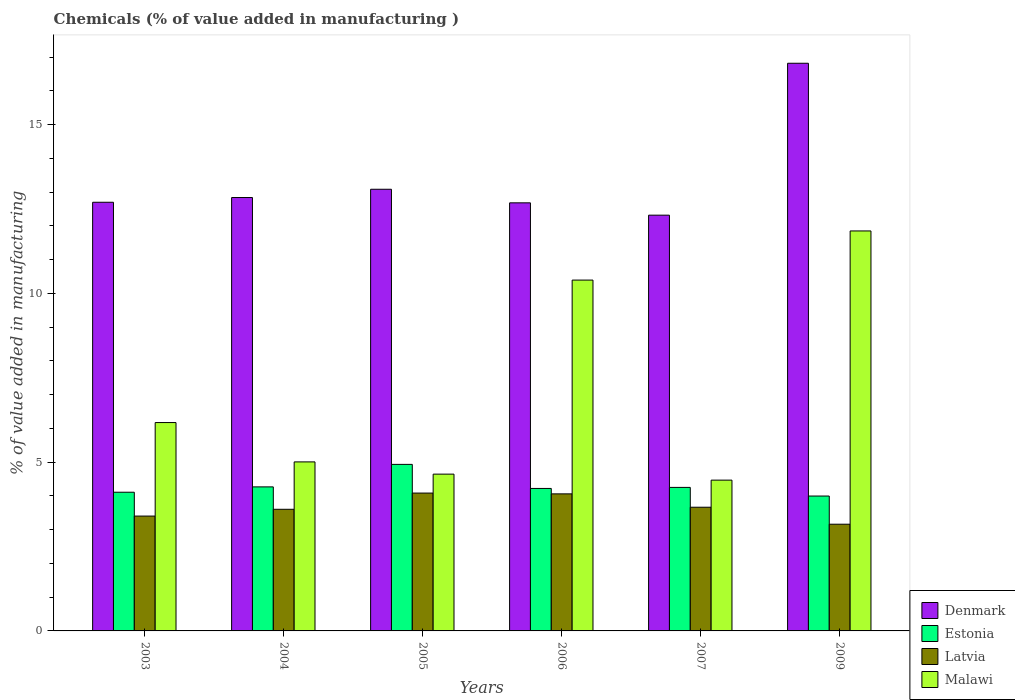How many different coloured bars are there?
Keep it short and to the point. 4. How many groups of bars are there?
Keep it short and to the point. 6. Are the number of bars per tick equal to the number of legend labels?
Offer a terse response. Yes. How many bars are there on the 4th tick from the left?
Make the answer very short. 4. How many bars are there on the 3rd tick from the right?
Provide a short and direct response. 4. What is the label of the 4th group of bars from the left?
Offer a terse response. 2006. In how many cases, is the number of bars for a given year not equal to the number of legend labels?
Your answer should be very brief. 0. What is the value added in manufacturing chemicals in Denmark in 2005?
Your answer should be compact. 13.08. Across all years, what is the maximum value added in manufacturing chemicals in Denmark?
Offer a very short reply. 16.82. Across all years, what is the minimum value added in manufacturing chemicals in Denmark?
Offer a very short reply. 12.32. In which year was the value added in manufacturing chemicals in Denmark minimum?
Offer a very short reply. 2007. What is the total value added in manufacturing chemicals in Malawi in the graph?
Keep it short and to the point. 42.53. What is the difference between the value added in manufacturing chemicals in Latvia in 2006 and that in 2007?
Your response must be concise. 0.4. What is the difference between the value added in manufacturing chemicals in Latvia in 2007 and the value added in manufacturing chemicals in Malawi in 2003?
Your answer should be very brief. -2.51. What is the average value added in manufacturing chemicals in Denmark per year?
Your answer should be compact. 13.41. In the year 2004, what is the difference between the value added in manufacturing chemicals in Denmark and value added in manufacturing chemicals in Malawi?
Provide a short and direct response. 7.83. In how many years, is the value added in manufacturing chemicals in Denmark greater than 5 %?
Give a very brief answer. 6. What is the ratio of the value added in manufacturing chemicals in Estonia in 2005 to that in 2007?
Offer a terse response. 1.16. Is the value added in manufacturing chemicals in Denmark in 2007 less than that in 2009?
Provide a succinct answer. Yes. Is the difference between the value added in manufacturing chemicals in Denmark in 2004 and 2005 greater than the difference between the value added in manufacturing chemicals in Malawi in 2004 and 2005?
Provide a short and direct response. No. What is the difference between the highest and the second highest value added in manufacturing chemicals in Denmark?
Your answer should be compact. 3.73. What is the difference between the highest and the lowest value added in manufacturing chemicals in Denmark?
Offer a terse response. 4.5. Is the sum of the value added in manufacturing chemicals in Denmark in 2004 and 2009 greater than the maximum value added in manufacturing chemicals in Malawi across all years?
Give a very brief answer. Yes. Is it the case that in every year, the sum of the value added in manufacturing chemicals in Malawi and value added in manufacturing chemicals in Estonia is greater than the sum of value added in manufacturing chemicals in Latvia and value added in manufacturing chemicals in Denmark?
Make the answer very short. No. What does the 1st bar from the left in 2004 represents?
Your answer should be compact. Denmark. What does the 2nd bar from the right in 2003 represents?
Give a very brief answer. Latvia. Are all the bars in the graph horizontal?
Ensure brevity in your answer.  No. What is the difference between two consecutive major ticks on the Y-axis?
Your response must be concise. 5. Are the values on the major ticks of Y-axis written in scientific E-notation?
Keep it short and to the point. No. Does the graph contain any zero values?
Keep it short and to the point. No. Where does the legend appear in the graph?
Give a very brief answer. Bottom right. How many legend labels are there?
Offer a terse response. 4. What is the title of the graph?
Your answer should be very brief. Chemicals (% of value added in manufacturing ). Does "Iceland" appear as one of the legend labels in the graph?
Offer a very short reply. No. What is the label or title of the X-axis?
Your answer should be very brief. Years. What is the label or title of the Y-axis?
Make the answer very short. % of value added in manufacturing. What is the % of value added in manufacturing in Denmark in 2003?
Your answer should be very brief. 12.7. What is the % of value added in manufacturing of Estonia in 2003?
Your answer should be very brief. 4.11. What is the % of value added in manufacturing in Latvia in 2003?
Your response must be concise. 3.4. What is the % of value added in manufacturing in Malawi in 2003?
Ensure brevity in your answer.  6.17. What is the % of value added in manufacturing in Denmark in 2004?
Make the answer very short. 12.84. What is the % of value added in manufacturing of Estonia in 2004?
Ensure brevity in your answer.  4.27. What is the % of value added in manufacturing in Latvia in 2004?
Provide a short and direct response. 3.6. What is the % of value added in manufacturing in Malawi in 2004?
Keep it short and to the point. 5.01. What is the % of value added in manufacturing in Denmark in 2005?
Keep it short and to the point. 13.08. What is the % of value added in manufacturing of Estonia in 2005?
Your answer should be compact. 4.93. What is the % of value added in manufacturing of Latvia in 2005?
Your answer should be compact. 4.08. What is the % of value added in manufacturing in Malawi in 2005?
Ensure brevity in your answer.  4.64. What is the % of value added in manufacturing of Denmark in 2006?
Provide a succinct answer. 12.68. What is the % of value added in manufacturing of Estonia in 2006?
Your answer should be compact. 4.22. What is the % of value added in manufacturing in Latvia in 2006?
Ensure brevity in your answer.  4.06. What is the % of value added in manufacturing of Malawi in 2006?
Your answer should be compact. 10.39. What is the % of value added in manufacturing in Denmark in 2007?
Give a very brief answer. 12.32. What is the % of value added in manufacturing of Estonia in 2007?
Your response must be concise. 4.25. What is the % of value added in manufacturing in Latvia in 2007?
Provide a short and direct response. 3.66. What is the % of value added in manufacturing of Malawi in 2007?
Give a very brief answer. 4.47. What is the % of value added in manufacturing of Denmark in 2009?
Provide a succinct answer. 16.82. What is the % of value added in manufacturing in Estonia in 2009?
Provide a succinct answer. 4. What is the % of value added in manufacturing in Latvia in 2009?
Make the answer very short. 3.16. What is the % of value added in manufacturing of Malawi in 2009?
Your response must be concise. 11.85. Across all years, what is the maximum % of value added in manufacturing of Denmark?
Provide a short and direct response. 16.82. Across all years, what is the maximum % of value added in manufacturing in Estonia?
Offer a very short reply. 4.93. Across all years, what is the maximum % of value added in manufacturing of Latvia?
Offer a terse response. 4.08. Across all years, what is the maximum % of value added in manufacturing in Malawi?
Provide a succinct answer. 11.85. Across all years, what is the minimum % of value added in manufacturing in Denmark?
Offer a very short reply. 12.32. Across all years, what is the minimum % of value added in manufacturing in Estonia?
Ensure brevity in your answer.  4. Across all years, what is the minimum % of value added in manufacturing in Latvia?
Provide a succinct answer. 3.16. Across all years, what is the minimum % of value added in manufacturing of Malawi?
Provide a short and direct response. 4.47. What is the total % of value added in manufacturing in Denmark in the graph?
Your response must be concise. 80.44. What is the total % of value added in manufacturing of Estonia in the graph?
Keep it short and to the point. 25.78. What is the total % of value added in manufacturing of Latvia in the graph?
Give a very brief answer. 21.97. What is the total % of value added in manufacturing in Malawi in the graph?
Ensure brevity in your answer.  42.53. What is the difference between the % of value added in manufacturing in Denmark in 2003 and that in 2004?
Offer a very short reply. -0.14. What is the difference between the % of value added in manufacturing in Estonia in 2003 and that in 2004?
Offer a very short reply. -0.16. What is the difference between the % of value added in manufacturing of Latvia in 2003 and that in 2004?
Make the answer very short. -0.2. What is the difference between the % of value added in manufacturing of Malawi in 2003 and that in 2004?
Make the answer very short. 1.17. What is the difference between the % of value added in manufacturing of Denmark in 2003 and that in 2005?
Give a very brief answer. -0.39. What is the difference between the % of value added in manufacturing of Estonia in 2003 and that in 2005?
Provide a succinct answer. -0.82. What is the difference between the % of value added in manufacturing of Latvia in 2003 and that in 2005?
Keep it short and to the point. -0.68. What is the difference between the % of value added in manufacturing in Malawi in 2003 and that in 2005?
Your answer should be very brief. 1.53. What is the difference between the % of value added in manufacturing of Denmark in 2003 and that in 2006?
Offer a very short reply. 0.02. What is the difference between the % of value added in manufacturing in Estonia in 2003 and that in 2006?
Your answer should be compact. -0.11. What is the difference between the % of value added in manufacturing of Latvia in 2003 and that in 2006?
Keep it short and to the point. -0.66. What is the difference between the % of value added in manufacturing of Malawi in 2003 and that in 2006?
Ensure brevity in your answer.  -4.22. What is the difference between the % of value added in manufacturing of Denmark in 2003 and that in 2007?
Keep it short and to the point. 0.38. What is the difference between the % of value added in manufacturing in Estonia in 2003 and that in 2007?
Offer a very short reply. -0.14. What is the difference between the % of value added in manufacturing in Latvia in 2003 and that in 2007?
Your response must be concise. -0.26. What is the difference between the % of value added in manufacturing in Malawi in 2003 and that in 2007?
Ensure brevity in your answer.  1.71. What is the difference between the % of value added in manufacturing in Denmark in 2003 and that in 2009?
Make the answer very short. -4.12. What is the difference between the % of value added in manufacturing in Estonia in 2003 and that in 2009?
Your answer should be compact. 0.11. What is the difference between the % of value added in manufacturing of Latvia in 2003 and that in 2009?
Make the answer very short. 0.24. What is the difference between the % of value added in manufacturing in Malawi in 2003 and that in 2009?
Offer a terse response. -5.68. What is the difference between the % of value added in manufacturing in Denmark in 2004 and that in 2005?
Ensure brevity in your answer.  -0.24. What is the difference between the % of value added in manufacturing of Latvia in 2004 and that in 2005?
Provide a succinct answer. -0.48. What is the difference between the % of value added in manufacturing in Malawi in 2004 and that in 2005?
Give a very brief answer. 0.36. What is the difference between the % of value added in manufacturing in Denmark in 2004 and that in 2006?
Provide a short and direct response. 0.16. What is the difference between the % of value added in manufacturing of Estonia in 2004 and that in 2006?
Give a very brief answer. 0.05. What is the difference between the % of value added in manufacturing in Latvia in 2004 and that in 2006?
Your answer should be very brief. -0.46. What is the difference between the % of value added in manufacturing in Malawi in 2004 and that in 2006?
Provide a short and direct response. -5.39. What is the difference between the % of value added in manufacturing in Denmark in 2004 and that in 2007?
Ensure brevity in your answer.  0.52. What is the difference between the % of value added in manufacturing of Estonia in 2004 and that in 2007?
Offer a terse response. 0.02. What is the difference between the % of value added in manufacturing of Latvia in 2004 and that in 2007?
Give a very brief answer. -0.06. What is the difference between the % of value added in manufacturing in Malawi in 2004 and that in 2007?
Keep it short and to the point. 0.54. What is the difference between the % of value added in manufacturing in Denmark in 2004 and that in 2009?
Ensure brevity in your answer.  -3.98. What is the difference between the % of value added in manufacturing in Estonia in 2004 and that in 2009?
Make the answer very short. 0.27. What is the difference between the % of value added in manufacturing in Latvia in 2004 and that in 2009?
Give a very brief answer. 0.44. What is the difference between the % of value added in manufacturing of Malawi in 2004 and that in 2009?
Your answer should be very brief. -6.84. What is the difference between the % of value added in manufacturing in Denmark in 2005 and that in 2006?
Offer a very short reply. 0.4. What is the difference between the % of value added in manufacturing in Estonia in 2005 and that in 2006?
Your answer should be very brief. 0.71. What is the difference between the % of value added in manufacturing in Latvia in 2005 and that in 2006?
Ensure brevity in your answer.  0.02. What is the difference between the % of value added in manufacturing in Malawi in 2005 and that in 2006?
Provide a short and direct response. -5.75. What is the difference between the % of value added in manufacturing in Denmark in 2005 and that in 2007?
Your response must be concise. 0.77. What is the difference between the % of value added in manufacturing of Estonia in 2005 and that in 2007?
Ensure brevity in your answer.  0.68. What is the difference between the % of value added in manufacturing of Latvia in 2005 and that in 2007?
Provide a short and direct response. 0.42. What is the difference between the % of value added in manufacturing in Malawi in 2005 and that in 2007?
Make the answer very short. 0.18. What is the difference between the % of value added in manufacturing of Denmark in 2005 and that in 2009?
Provide a short and direct response. -3.73. What is the difference between the % of value added in manufacturing in Estonia in 2005 and that in 2009?
Your response must be concise. 0.94. What is the difference between the % of value added in manufacturing of Latvia in 2005 and that in 2009?
Keep it short and to the point. 0.92. What is the difference between the % of value added in manufacturing of Malawi in 2005 and that in 2009?
Your answer should be very brief. -7.2. What is the difference between the % of value added in manufacturing of Denmark in 2006 and that in 2007?
Your response must be concise. 0.37. What is the difference between the % of value added in manufacturing of Estonia in 2006 and that in 2007?
Your response must be concise. -0.03. What is the difference between the % of value added in manufacturing of Latvia in 2006 and that in 2007?
Your answer should be very brief. 0.4. What is the difference between the % of value added in manufacturing of Malawi in 2006 and that in 2007?
Provide a succinct answer. 5.93. What is the difference between the % of value added in manufacturing in Denmark in 2006 and that in 2009?
Your answer should be very brief. -4.13. What is the difference between the % of value added in manufacturing of Estonia in 2006 and that in 2009?
Your answer should be very brief. 0.22. What is the difference between the % of value added in manufacturing of Latvia in 2006 and that in 2009?
Provide a succinct answer. 0.9. What is the difference between the % of value added in manufacturing of Malawi in 2006 and that in 2009?
Give a very brief answer. -1.46. What is the difference between the % of value added in manufacturing in Denmark in 2007 and that in 2009?
Keep it short and to the point. -4.5. What is the difference between the % of value added in manufacturing in Estonia in 2007 and that in 2009?
Provide a succinct answer. 0.26. What is the difference between the % of value added in manufacturing of Latvia in 2007 and that in 2009?
Offer a terse response. 0.5. What is the difference between the % of value added in manufacturing in Malawi in 2007 and that in 2009?
Offer a very short reply. -7.38. What is the difference between the % of value added in manufacturing of Denmark in 2003 and the % of value added in manufacturing of Estonia in 2004?
Offer a very short reply. 8.43. What is the difference between the % of value added in manufacturing in Denmark in 2003 and the % of value added in manufacturing in Latvia in 2004?
Your answer should be compact. 9.1. What is the difference between the % of value added in manufacturing of Denmark in 2003 and the % of value added in manufacturing of Malawi in 2004?
Offer a very short reply. 7.69. What is the difference between the % of value added in manufacturing in Estonia in 2003 and the % of value added in manufacturing in Latvia in 2004?
Offer a terse response. 0.51. What is the difference between the % of value added in manufacturing in Estonia in 2003 and the % of value added in manufacturing in Malawi in 2004?
Your answer should be very brief. -0.9. What is the difference between the % of value added in manufacturing in Latvia in 2003 and the % of value added in manufacturing in Malawi in 2004?
Make the answer very short. -1.6. What is the difference between the % of value added in manufacturing in Denmark in 2003 and the % of value added in manufacturing in Estonia in 2005?
Your response must be concise. 7.77. What is the difference between the % of value added in manufacturing of Denmark in 2003 and the % of value added in manufacturing of Latvia in 2005?
Offer a very short reply. 8.62. What is the difference between the % of value added in manufacturing in Denmark in 2003 and the % of value added in manufacturing in Malawi in 2005?
Your answer should be very brief. 8.05. What is the difference between the % of value added in manufacturing of Estonia in 2003 and the % of value added in manufacturing of Latvia in 2005?
Your response must be concise. 0.02. What is the difference between the % of value added in manufacturing in Estonia in 2003 and the % of value added in manufacturing in Malawi in 2005?
Offer a very short reply. -0.54. What is the difference between the % of value added in manufacturing in Latvia in 2003 and the % of value added in manufacturing in Malawi in 2005?
Your answer should be very brief. -1.24. What is the difference between the % of value added in manufacturing of Denmark in 2003 and the % of value added in manufacturing of Estonia in 2006?
Your response must be concise. 8.48. What is the difference between the % of value added in manufacturing in Denmark in 2003 and the % of value added in manufacturing in Latvia in 2006?
Give a very brief answer. 8.64. What is the difference between the % of value added in manufacturing in Denmark in 2003 and the % of value added in manufacturing in Malawi in 2006?
Give a very brief answer. 2.31. What is the difference between the % of value added in manufacturing in Estonia in 2003 and the % of value added in manufacturing in Latvia in 2006?
Make the answer very short. 0.05. What is the difference between the % of value added in manufacturing of Estonia in 2003 and the % of value added in manufacturing of Malawi in 2006?
Give a very brief answer. -6.28. What is the difference between the % of value added in manufacturing of Latvia in 2003 and the % of value added in manufacturing of Malawi in 2006?
Keep it short and to the point. -6.99. What is the difference between the % of value added in manufacturing in Denmark in 2003 and the % of value added in manufacturing in Estonia in 2007?
Make the answer very short. 8.45. What is the difference between the % of value added in manufacturing of Denmark in 2003 and the % of value added in manufacturing of Latvia in 2007?
Offer a very short reply. 9.03. What is the difference between the % of value added in manufacturing of Denmark in 2003 and the % of value added in manufacturing of Malawi in 2007?
Keep it short and to the point. 8.23. What is the difference between the % of value added in manufacturing in Estonia in 2003 and the % of value added in manufacturing in Latvia in 2007?
Your response must be concise. 0.44. What is the difference between the % of value added in manufacturing of Estonia in 2003 and the % of value added in manufacturing of Malawi in 2007?
Your response must be concise. -0.36. What is the difference between the % of value added in manufacturing of Latvia in 2003 and the % of value added in manufacturing of Malawi in 2007?
Your answer should be very brief. -1.06. What is the difference between the % of value added in manufacturing of Denmark in 2003 and the % of value added in manufacturing of Estonia in 2009?
Make the answer very short. 8.7. What is the difference between the % of value added in manufacturing in Denmark in 2003 and the % of value added in manufacturing in Latvia in 2009?
Provide a succinct answer. 9.54. What is the difference between the % of value added in manufacturing in Denmark in 2003 and the % of value added in manufacturing in Malawi in 2009?
Provide a short and direct response. 0.85. What is the difference between the % of value added in manufacturing of Estonia in 2003 and the % of value added in manufacturing of Latvia in 2009?
Your answer should be compact. 0.95. What is the difference between the % of value added in manufacturing of Estonia in 2003 and the % of value added in manufacturing of Malawi in 2009?
Make the answer very short. -7.74. What is the difference between the % of value added in manufacturing of Latvia in 2003 and the % of value added in manufacturing of Malawi in 2009?
Give a very brief answer. -8.45. What is the difference between the % of value added in manufacturing of Denmark in 2004 and the % of value added in manufacturing of Estonia in 2005?
Your answer should be compact. 7.91. What is the difference between the % of value added in manufacturing in Denmark in 2004 and the % of value added in manufacturing in Latvia in 2005?
Your response must be concise. 8.76. What is the difference between the % of value added in manufacturing of Denmark in 2004 and the % of value added in manufacturing of Malawi in 2005?
Offer a terse response. 8.19. What is the difference between the % of value added in manufacturing in Estonia in 2004 and the % of value added in manufacturing in Latvia in 2005?
Your answer should be very brief. 0.18. What is the difference between the % of value added in manufacturing of Estonia in 2004 and the % of value added in manufacturing of Malawi in 2005?
Your response must be concise. -0.38. What is the difference between the % of value added in manufacturing of Latvia in 2004 and the % of value added in manufacturing of Malawi in 2005?
Offer a very short reply. -1.04. What is the difference between the % of value added in manufacturing of Denmark in 2004 and the % of value added in manufacturing of Estonia in 2006?
Provide a short and direct response. 8.62. What is the difference between the % of value added in manufacturing in Denmark in 2004 and the % of value added in manufacturing in Latvia in 2006?
Ensure brevity in your answer.  8.78. What is the difference between the % of value added in manufacturing of Denmark in 2004 and the % of value added in manufacturing of Malawi in 2006?
Keep it short and to the point. 2.45. What is the difference between the % of value added in manufacturing in Estonia in 2004 and the % of value added in manufacturing in Latvia in 2006?
Offer a very short reply. 0.21. What is the difference between the % of value added in manufacturing in Estonia in 2004 and the % of value added in manufacturing in Malawi in 2006?
Give a very brief answer. -6.13. What is the difference between the % of value added in manufacturing in Latvia in 2004 and the % of value added in manufacturing in Malawi in 2006?
Your response must be concise. -6.79. What is the difference between the % of value added in manufacturing in Denmark in 2004 and the % of value added in manufacturing in Estonia in 2007?
Your answer should be very brief. 8.59. What is the difference between the % of value added in manufacturing in Denmark in 2004 and the % of value added in manufacturing in Latvia in 2007?
Offer a terse response. 9.17. What is the difference between the % of value added in manufacturing in Denmark in 2004 and the % of value added in manufacturing in Malawi in 2007?
Provide a succinct answer. 8.37. What is the difference between the % of value added in manufacturing of Estonia in 2004 and the % of value added in manufacturing of Latvia in 2007?
Offer a terse response. 0.6. What is the difference between the % of value added in manufacturing in Estonia in 2004 and the % of value added in manufacturing in Malawi in 2007?
Keep it short and to the point. -0.2. What is the difference between the % of value added in manufacturing of Latvia in 2004 and the % of value added in manufacturing of Malawi in 2007?
Keep it short and to the point. -0.86. What is the difference between the % of value added in manufacturing in Denmark in 2004 and the % of value added in manufacturing in Estonia in 2009?
Make the answer very short. 8.84. What is the difference between the % of value added in manufacturing in Denmark in 2004 and the % of value added in manufacturing in Latvia in 2009?
Your answer should be compact. 9.68. What is the difference between the % of value added in manufacturing in Estonia in 2004 and the % of value added in manufacturing in Latvia in 2009?
Make the answer very short. 1.11. What is the difference between the % of value added in manufacturing of Estonia in 2004 and the % of value added in manufacturing of Malawi in 2009?
Your answer should be very brief. -7.58. What is the difference between the % of value added in manufacturing of Latvia in 2004 and the % of value added in manufacturing of Malawi in 2009?
Your answer should be compact. -8.25. What is the difference between the % of value added in manufacturing in Denmark in 2005 and the % of value added in manufacturing in Estonia in 2006?
Your response must be concise. 8.86. What is the difference between the % of value added in manufacturing of Denmark in 2005 and the % of value added in manufacturing of Latvia in 2006?
Provide a short and direct response. 9.02. What is the difference between the % of value added in manufacturing of Denmark in 2005 and the % of value added in manufacturing of Malawi in 2006?
Your answer should be very brief. 2.69. What is the difference between the % of value added in manufacturing in Estonia in 2005 and the % of value added in manufacturing in Latvia in 2006?
Provide a short and direct response. 0.87. What is the difference between the % of value added in manufacturing of Estonia in 2005 and the % of value added in manufacturing of Malawi in 2006?
Offer a very short reply. -5.46. What is the difference between the % of value added in manufacturing of Latvia in 2005 and the % of value added in manufacturing of Malawi in 2006?
Offer a terse response. -6.31. What is the difference between the % of value added in manufacturing in Denmark in 2005 and the % of value added in manufacturing in Estonia in 2007?
Give a very brief answer. 8.83. What is the difference between the % of value added in manufacturing of Denmark in 2005 and the % of value added in manufacturing of Latvia in 2007?
Give a very brief answer. 9.42. What is the difference between the % of value added in manufacturing in Denmark in 2005 and the % of value added in manufacturing in Malawi in 2007?
Give a very brief answer. 8.62. What is the difference between the % of value added in manufacturing of Estonia in 2005 and the % of value added in manufacturing of Latvia in 2007?
Offer a terse response. 1.27. What is the difference between the % of value added in manufacturing of Estonia in 2005 and the % of value added in manufacturing of Malawi in 2007?
Ensure brevity in your answer.  0.47. What is the difference between the % of value added in manufacturing of Latvia in 2005 and the % of value added in manufacturing of Malawi in 2007?
Keep it short and to the point. -0.38. What is the difference between the % of value added in manufacturing in Denmark in 2005 and the % of value added in manufacturing in Estonia in 2009?
Offer a terse response. 9.09. What is the difference between the % of value added in manufacturing of Denmark in 2005 and the % of value added in manufacturing of Latvia in 2009?
Give a very brief answer. 9.92. What is the difference between the % of value added in manufacturing of Denmark in 2005 and the % of value added in manufacturing of Malawi in 2009?
Your answer should be compact. 1.23. What is the difference between the % of value added in manufacturing in Estonia in 2005 and the % of value added in manufacturing in Latvia in 2009?
Offer a very short reply. 1.77. What is the difference between the % of value added in manufacturing in Estonia in 2005 and the % of value added in manufacturing in Malawi in 2009?
Ensure brevity in your answer.  -6.92. What is the difference between the % of value added in manufacturing of Latvia in 2005 and the % of value added in manufacturing of Malawi in 2009?
Provide a short and direct response. -7.77. What is the difference between the % of value added in manufacturing in Denmark in 2006 and the % of value added in manufacturing in Estonia in 2007?
Ensure brevity in your answer.  8.43. What is the difference between the % of value added in manufacturing of Denmark in 2006 and the % of value added in manufacturing of Latvia in 2007?
Provide a succinct answer. 9.02. What is the difference between the % of value added in manufacturing in Denmark in 2006 and the % of value added in manufacturing in Malawi in 2007?
Your answer should be compact. 8.21. What is the difference between the % of value added in manufacturing of Estonia in 2006 and the % of value added in manufacturing of Latvia in 2007?
Your answer should be very brief. 0.56. What is the difference between the % of value added in manufacturing in Estonia in 2006 and the % of value added in manufacturing in Malawi in 2007?
Offer a very short reply. -0.25. What is the difference between the % of value added in manufacturing of Latvia in 2006 and the % of value added in manufacturing of Malawi in 2007?
Ensure brevity in your answer.  -0.41. What is the difference between the % of value added in manufacturing in Denmark in 2006 and the % of value added in manufacturing in Estonia in 2009?
Your answer should be very brief. 8.69. What is the difference between the % of value added in manufacturing of Denmark in 2006 and the % of value added in manufacturing of Latvia in 2009?
Your answer should be compact. 9.52. What is the difference between the % of value added in manufacturing of Denmark in 2006 and the % of value added in manufacturing of Malawi in 2009?
Keep it short and to the point. 0.83. What is the difference between the % of value added in manufacturing in Estonia in 2006 and the % of value added in manufacturing in Latvia in 2009?
Keep it short and to the point. 1.06. What is the difference between the % of value added in manufacturing of Estonia in 2006 and the % of value added in manufacturing of Malawi in 2009?
Your response must be concise. -7.63. What is the difference between the % of value added in manufacturing in Latvia in 2006 and the % of value added in manufacturing in Malawi in 2009?
Give a very brief answer. -7.79. What is the difference between the % of value added in manufacturing in Denmark in 2007 and the % of value added in manufacturing in Estonia in 2009?
Make the answer very short. 8.32. What is the difference between the % of value added in manufacturing of Denmark in 2007 and the % of value added in manufacturing of Latvia in 2009?
Give a very brief answer. 9.16. What is the difference between the % of value added in manufacturing of Denmark in 2007 and the % of value added in manufacturing of Malawi in 2009?
Your answer should be compact. 0.47. What is the difference between the % of value added in manufacturing of Estonia in 2007 and the % of value added in manufacturing of Latvia in 2009?
Make the answer very short. 1.09. What is the difference between the % of value added in manufacturing of Estonia in 2007 and the % of value added in manufacturing of Malawi in 2009?
Ensure brevity in your answer.  -7.6. What is the difference between the % of value added in manufacturing in Latvia in 2007 and the % of value added in manufacturing in Malawi in 2009?
Keep it short and to the point. -8.18. What is the average % of value added in manufacturing of Denmark per year?
Give a very brief answer. 13.41. What is the average % of value added in manufacturing of Estonia per year?
Your answer should be compact. 4.3. What is the average % of value added in manufacturing of Latvia per year?
Ensure brevity in your answer.  3.66. What is the average % of value added in manufacturing of Malawi per year?
Your response must be concise. 7.09. In the year 2003, what is the difference between the % of value added in manufacturing in Denmark and % of value added in manufacturing in Estonia?
Offer a very short reply. 8.59. In the year 2003, what is the difference between the % of value added in manufacturing of Denmark and % of value added in manufacturing of Latvia?
Offer a terse response. 9.3. In the year 2003, what is the difference between the % of value added in manufacturing in Denmark and % of value added in manufacturing in Malawi?
Provide a short and direct response. 6.53. In the year 2003, what is the difference between the % of value added in manufacturing of Estonia and % of value added in manufacturing of Latvia?
Provide a succinct answer. 0.71. In the year 2003, what is the difference between the % of value added in manufacturing of Estonia and % of value added in manufacturing of Malawi?
Offer a terse response. -2.06. In the year 2003, what is the difference between the % of value added in manufacturing of Latvia and % of value added in manufacturing of Malawi?
Your answer should be compact. -2.77. In the year 2004, what is the difference between the % of value added in manufacturing of Denmark and % of value added in manufacturing of Estonia?
Provide a succinct answer. 8.57. In the year 2004, what is the difference between the % of value added in manufacturing in Denmark and % of value added in manufacturing in Latvia?
Offer a terse response. 9.24. In the year 2004, what is the difference between the % of value added in manufacturing in Denmark and % of value added in manufacturing in Malawi?
Keep it short and to the point. 7.83. In the year 2004, what is the difference between the % of value added in manufacturing in Estonia and % of value added in manufacturing in Latvia?
Ensure brevity in your answer.  0.66. In the year 2004, what is the difference between the % of value added in manufacturing of Estonia and % of value added in manufacturing of Malawi?
Keep it short and to the point. -0.74. In the year 2004, what is the difference between the % of value added in manufacturing in Latvia and % of value added in manufacturing in Malawi?
Your answer should be compact. -1.4. In the year 2005, what is the difference between the % of value added in manufacturing of Denmark and % of value added in manufacturing of Estonia?
Ensure brevity in your answer.  8.15. In the year 2005, what is the difference between the % of value added in manufacturing in Denmark and % of value added in manufacturing in Latvia?
Your answer should be compact. 9. In the year 2005, what is the difference between the % of value added in manufacturing in Denmark and % of value added in manufacturing in Malawi?
Keep it short and to the point. 8.44. In the year 2005, what is the difference between the % of value added in manufacturing in Estonia and % of value added in manufacturing in Latvia?
Your answer should be very brief. 0.85. In the year 2005, what is the difference between the % of value added in manufacturing of Estonia and % of value added in manufacturing of Malawi?
Your answer should be compact. 0.29. In the year 2005, what is the difference between the % of value added in manufacturing of Latvia and % of value added in manufacturing of Malawi?
Your answer should be very brief. -0.56. In the year 2006, what is the difference between the % of value added in manufacturing in Denmark and % of value added in manufacturing in Estonia?
Your answer should be very brief. 8.46. In the year 2006, what is the difference between the % of value added in manufacturing in Denmark and % of value added in manufacturing in Latvia?
Provide a succinct answer. 8.62. In the year 2006, what is the difference between the % of value added in manufacturing of Denmark and % of value added in manufacturing of Malawi?
Provide a short and direct response. 2.29. In the year 2006, what is the difference between the % of value added in manufacturing of Estonia and % of value added in manufacturing of Latvia?
Your response must be concise. 0.16. In the year 2006, what is the difference between the % of value added in manufacturing in Estonia and % of value added in manufacturing in Malawi?
Offer a terse response. -6.17. In the year 2006, what is the difference between the % of value added in manufacturing of Latvia and % of value added in manufacturing of Malawi?
Your answer should be compact. -6.33. In the year 2007, what is the difference between the % of value added in manufacturing in Denmark and % of value added in manufacturing in Estonia?
Ensure brevity in your answer.  8.06. In the year 2007, what is the difference between the % of value added in manufacturing of Denmark and % of value added in manufacturing of Latvia?
Offer a terse response. 8.65. In the year 2007, what is the difference between the % of value added in manufacturing in Denmark and % of value added in manufacturing in Malawi?
Provide a short and direct response. 7.85. In the year 2007, what is the difference between the % of value added in manufacturing of Estonia and % of value added in manufacturing of Latvia?
Offer a very short reply. 0.59. In the year 2007, what is the difference between the % of value added in manufacturing of Estonia and % of value added in manufacturing of Malawi?
Your answer should be compact. -0.22. In the year 2007, what is the difference between the % of value added in manufacturing in Latvia and % of value added in manufacturing in Malawi?
Provide a short and direct response. -0.8. In the year 2009, what is the difference between the % of value added in manufacturing in Denmark and % of value added in manufacturing in Estonia?
Your response must be concise. 12.82. In the year 2009, what is the difference between the % of value added in manufacturing of Denmark and % of value added in manufacturing of Latvia?
Your answer should be very brief. 13.66. In the year 2009, what is the difference between the % of value added in manufacturing in Denmark and % of value added in manufacturing in Malawi?
Your answer should be very brief. 4.97. In the year 2009, what is the difference between the % of value added in manufacturing of Estonia and % of value added in manufacturing of Latvia?
Your answer should be compact. 0.83. In the year 2009, what is the difference between the % of value added in manufacturing of Estonia and % of value added in manufacturing of Malawi?
Your answer should be very brief. -7.85. In the year 2009, what is the difference between the % of value added in manufacturing of Latvia and % of value added in manufacturing of Malawi?
Keep it short and to the point. -8.69. What is the ratio of the % of value added in manufacturing in Denmark in 2003 to that in 2004?
Your answer should be compact. 0.99. What is the ratio of the % of value added in manufacturing in Estonia in 2003 to that in 2004?
Provide a short and direct response. 0.96. What is the ratio of the % of value added in manufacturing in Latvia in 2003 to that in 2004?
Ensure brevity in your answer.  0.94. What is the ratio of the % of value added in manufacturing in Malawi in 2003 to that in 2004?
Provide a short and direct response. 1.23. What is the ratio of the % of value added in manufacturing in Denmark in 2003 to that in 2005?
Your response must be concise. 0.97. What is the ratio of the % of value added in manufacturing in Estonia in 2003 to that in 2005?
Provide a short and direct response. 0.83. What is the ratio of the % of value added in manufacturing of Latvia in 2003 to that in 2005?
Give a very brief answer. 0.83. What is the ratio of the % of value added in manufacturing of Malawi in 2003 to that in 2005?
Your response must be concise. 1.33. What is the ratio of the % of value added in manufacturing of Denmark in 2003 to that in 2006?
Your answer should be very brief. 1. What is the ratio of the % of value added in manufacturing of Estonia in 2003 to that in 2006?
Your answer should be compact. 0.97. What is the ratio of the % of value added in manufacturing of Latvia in 2003 to that in 2006?
Your response must be concise. 0.84. What is the ratio of the % of value added in manufacturing of Malawi in 2003 to that in 2006?
Your response must be concise. 0.59. What is the ratio of the % of value added in manufacturing in Denmark in 2003 to that in 2007?
Provide a short and direct response. 1.03. What is the ratio of the % of value added in manufacturing of Estonia in 2003 to that in 2007?
Your answer should be compact. 0.97. What is the ratio of the % of value added in manufacturing of Latvia in 2003 to that in 2007?
Keep it short and to the point. 0.93. What is the ratio of the % of value added in manufacturing in Malawi in 2003 to that in 2007?
Provide a succinct answer. 1.38. What is the ratio of the % of value added in manufacturing in Denmark in 2003 to that in 2009?
Ensure brevity in your answer.  0.76. What is the ratio of the % of value added in manufacturing in Estonia in 2003 to that in 2009?
Give a very brief answer. 1.03. What is the ratio of the % of value added in manufacturing in Latvia in 2003 to that in 2009?
Provide a short and direct response. 1.08. What is the ratio of the % of value added in manufacturing in Malawi in 2003 to that in 2009?
Make the answer very short. 0.52. What is the ratio of the % of value added in manufacturing of Denmark in 2004 to that in 2005?
Provide a succinct answer. 0.98. What is the ratio of the % of value added in manufacturing in Estonia in 2004 to that in 2005?
Offer a very short reply. 0.86. What is the ratio of the % of value added in manufacturing of Latvia in 2004 to that in 2005?
Offer a very short reply. 0.88. What is the ratio of the % of value added in manufacturing in Malawi in 2004 to that in 2005?
Your answer should be compact. 1.08. What is the ratio of the % of value added in manufacturing of Denmark in 2004 to that in 2006?
Offer a terse response. 1.01. What is the ratio of the % of value added in manufacturing in Estonia in 2004 to that in 2006?
Your answer should be very brief. 1.01. What is the ratio of the % of value added in manufacturing of Latvia in 2004 to that in 2006?
Your answer should be very brief. 0.89. What is the ratio of the % of value added in manufacturing in Malawi in 2004 to that in 2006?
Give a very brief answer. 0.48. What is the ratio of the % of value added in manufacturing in Denmark in 2004 to that in 2007?
Keep it short and to the point. 1.04. What is the ratio of the % of value added in manufacturing of Estonia in 2004 to that in 2007?
Offer a terse response. 1. What is the ratio of the % of value added in manufacturing of Latvia in 2004 to that in 2007?
Make the answer very short. 0.98. What is the ratio of the % of value added in manufacturing in Malawi in 2004 to that in 2007?
Keep it short and to the point. 1.12. What is the ratio of the % of value added in manufacturing in Denmark in 2004 to that in 2009?
Provide a short and direct response. 0.76. What is the ratio of the % of value added in manufacturing of Estonia in 2004 to that in 2009?
Provide a succinct answer. 1.07. What is the ratio of the % of value added in manufacturing of Latvia in 2004 to that in 2009?
Give a very brief answer. 1.14. What is the ratio of the % of value added in manufacturing of Malawi in 2004 to that in 2009?
Your answer should be very brief. 0.42. What is the ratio of the % of value added in manufacturing in Denmark in 2005 to that in 2006?
Offer a very short reply. 1.03. What is the ratio of the % of value added in manufacturing in Estonia in 2005 to that in 2006?
Provide a succinct answer. 1.17. What is the ratio of the % of value added in manufacturing of Latvia in 2005 to that in 2006?
Your answer should be very brief. 1.01. What is the ratio of the % of value added in manufacturing in Malawi in 2005 to that in 2006?
Offer a terse response. 0.45. What is the ratio of the % of value added in manufacturing of Denmark in 2005 to that in 2007?
Provide a short and direct response. 1.06. What is the ratio of the % of value added in manufacturing of Estonia in 2005 to that in 2007?
Ensure brevity in your answer.  1.16. What is the ratio of the % of value added in manufacturing of Latvia in 2005 to that in 2007?
Offer a very short reply. 1.11. What is the ratio of the % of value added in manufacturing of Malawi in 2005 to that in 2007?
Your response must be concise. 1.04. What is the ratio of the % of value added in manufacturing in Denmark in 2005 to that in 2009?
Make the answer very short. 0.78. What is the ratio of the % of value added in manufacturing in Estonia in 2005 to that in 2009?
Give a very brief answer. 1.23. What is the ratio of the % of value added in manufacturing of Latvia in 2005 to that in 2009?
Keep it short and to the point. 1.29. What is the ratio of the % of value added in manufacturing in Malawi in 2005 to that in 2009?
Keep it short and to the point. 0.39. What is the ratio of the % of value added in manufacturing in Denmark in 2006 to that in 2007?
Make the answer very short. 1.03. What is the ratio of the % of value added in manufacturing of Latvia in 2006 to that in 2007?
Offer a very short reply. 1.11. What is the ratio of the % of value added in manufacturing of Malawi in 2006 to that in 2007?
Your response must be concise. 2.33. What is the ratio of the % of value added in manufacturing of Denmark in 2006 to that in 2009?
Your answer should be very brief. 0.75. What is the ratio of the % of value added in manufacturing in Estonia in 2006 to that in 2009?
Your response must be concise. 1.06. What is the ratio of the % of value added in manufacturing of Latvia in 2006 to that in 2009?
Provide a succinct answer. 1.28. What is the ratio of the % of value added in manufacturing of Malawi in 2006 to that in 2009?
Offer a terse response. 0.88. What is the ratio of the % of value added in manufacturing in Denmark in 2007 to that in 2009?
Make the answer very short. 0.73. What is the ratio of the % of value added in manufacturing in Estonia in 2007 to that in 2009?
Make the answer very short. 1.06. What is the ratio of the % of value added in manufacturing in Latvia in 2007 to that in 2009?
Provide a short and direct response. 1.16. What is the ratio of the % of value added in manufacturing of Malawi in 2007 to that in 2009?
Offer a terse response. 0.38. What is the difference between the highest and the second highest % of value added in manufacturing of Denmark?
Make the answer very short. 3.73. What is the difference between the highest and the second highest % of value added in manufacturing of Latvia?
Keep it short and to the point. 0.02. What is the difference between the highest and the second highest % of value added in manufacturing of Malawi?
Ensure brevity in your answer.  1.46. What is the difference between the highest and the lowest % of value added in manufacturing of Denmark?
Your answer should be compact. 4.5. What is the difference between the highest and the lowest % of value added in manufacturing of Estonia?
Your answer should be very brief. 0.94. What is the difference between the highest and the lowest % of value added in manufacturing in Latvia?
Your response must be concise. 0.92. What is the difference between the highest and the lowest % of value added in manufacturing in Malawi?
Keep it short and to the point. 7.38. 